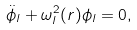Convert formula to latex. <formula><loc_0><loc_0><loc_500><loc_500>\ddot { \phi } _ { l } + \omega _ { l } ^ { 2 } ( r ) { \phi } _ { l } = 0 ,</formula> 